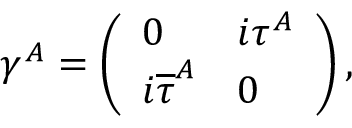Convert formula to latex. <formula><loc_0><loc_0><loc_500><loc_500>\gamma ^ { A } = \left ( \begin{array} { l l } { 0 } & { { i \tau ^ { A } } } \\ { { i { \overline { \tau } } ^ { A } } } & { 0 } \end{array} \right ) ,</formula> 